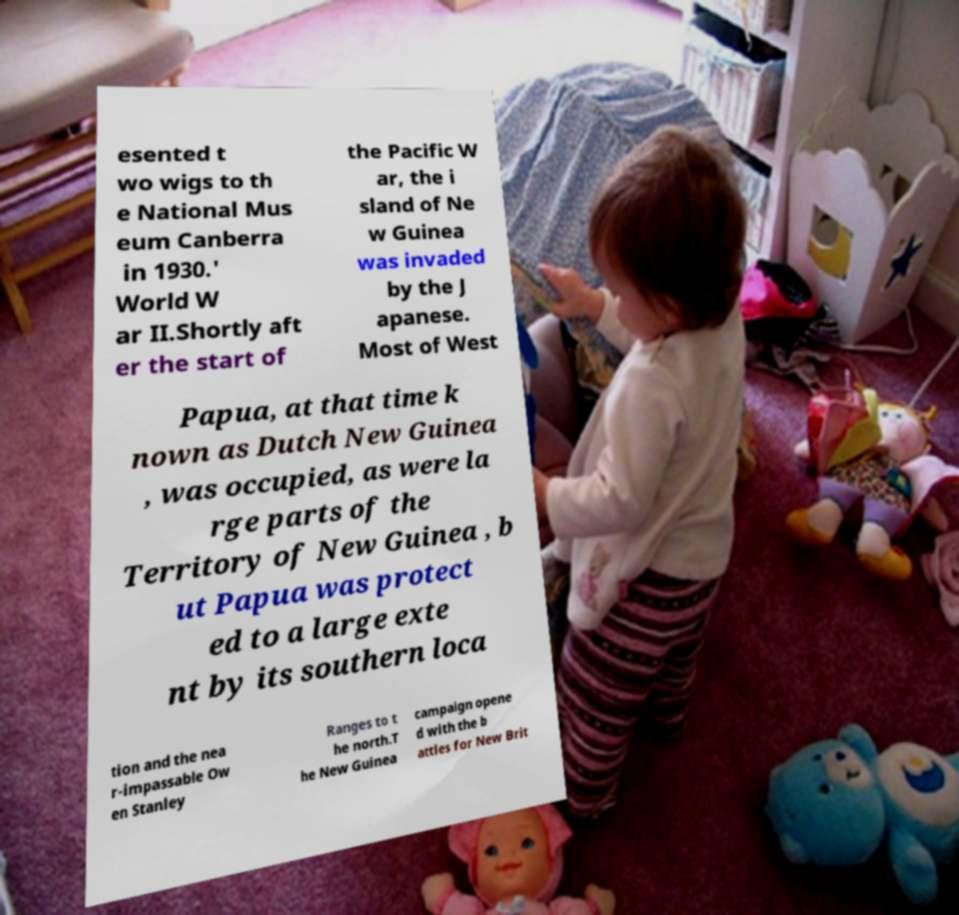Can you read and provide the text displayed in the image?This photo seems to have some interesting text. Can you extract and type it out for me? esented t wo wigs to th e National Mus eum Canberra in 1930.' World W ar II.Shortly aft er the start of the Pacific W ar, the i sland of Ne w Guinea was invaded by the J apanese. Most of West Papua, at that time k nown as Dutch New Guinea , was occupied, as were la rge parts of the Territory of New Guinea , b ut Papua was protect ed to a large exte nt by its southern loca tion and the nea r-impassable Ow en Stanley Ranges to t he north.T he New Guinea campaign opene d with the b attles for New Brit 